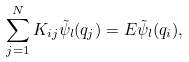Convert formula to latex. <formula><loc_0><loc_0><loc_500><loc_500>\sum _ { j = 1 } ^ { N } K _ { i j } \tilde { \psi } _ { l } ( q _ { j } ) = E \tilde { \psi } _ { l } ( q _ { i } ) ,</formula> 